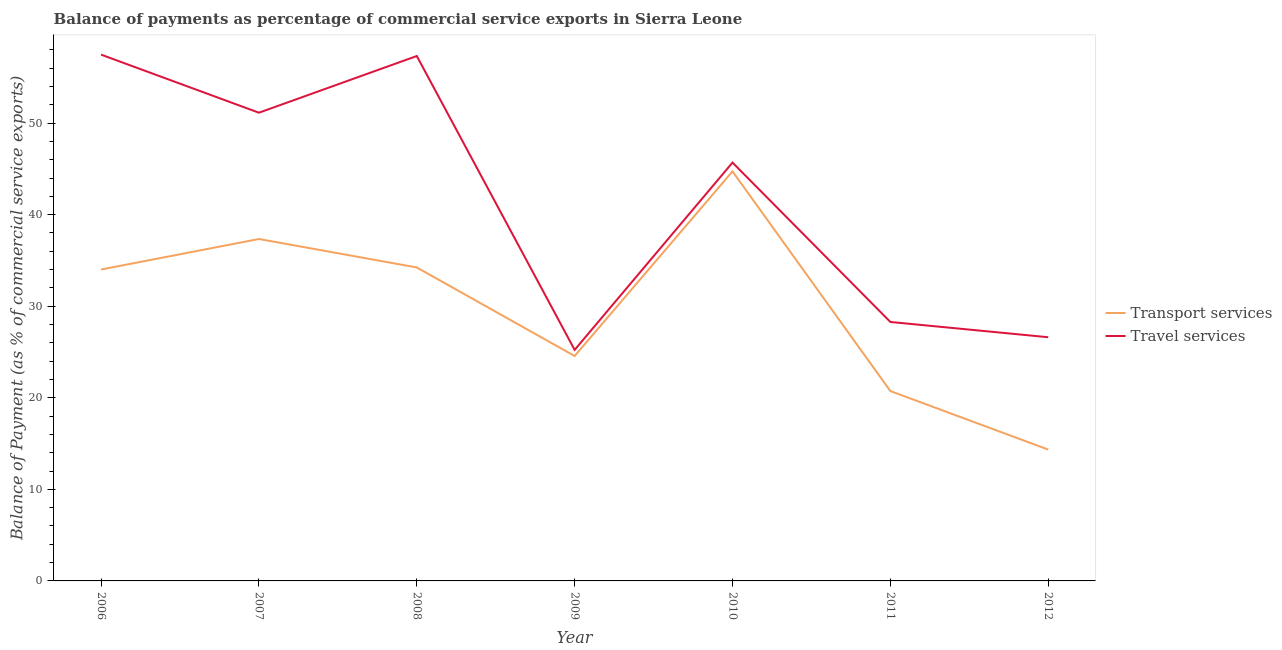How many different coloured lines are there?
Your answer should be compact. 2. Does the line corresponding to balance of payments of travel services intersect with the line corresponding to balance of payments of transport services?
Offer a very short reply. No. Is the number of lines equal to the number of legend labels?
Give a very brief answer. Yes. What is the balance of payments of travel services in 2012?
Provide a succinct answer. 26.61. Across all years, what is the maximum balance of payments of transport services?
Your answer should be compact. 44.72. Across all years, what is the minimum balance of payments of transport services?
Provide a succinct answer. 14.34. In which year was the balance of payments of transport services maximum?
Your answer should be compact. 2010. What is the total balance of payments of travel services in the graph?
Make the answer very short. 291.73. What is the difference between the balance of payments of transport services in 2008 and that in 2010?
Make the answer very short. -10.49. What is the difference between the balance of payments of transport services in 2012 and the balance of payments of travel services in 2006?
Your response must be concise. -43.13. What is the average balance of payments of transport services per year?
Offer a very short reply. 29.99. In the year 2011, what is the difference between the balance of payments of travel services and balance of payments of transport services?
Ensure brevity in your answer.  7.54. What is the ratio of the balance of payments of transport services in 2008 to that in 2010?
Offer a terse response. 0.77. Is the difference between the balance of payments of travel services in 2006 and 2011 greater than the difference between the balance of payments of transport services in 2006 and 2011?
Ensure brevity in your answer.  Yes. What is the difference between the highest and the second highest balance of payments of travel services?
Keep it short and to the point. 0.15. What is the difference between the highest and the lowest balance of payments of transport services?
Your response must be concise. 30.38. In how many years, is the balance of payments of transport services greater than the average balance of payments of transport services taken over all years?
Make the answer very short. 4. Does the balance of payments of transport services monotonically increase over the years?
Your answer should be very brief. No. Is the balance of payments of travel services strictly less than the balance of payments of transport services over the years?
Make the answer very short. No. Does the graph contain any zero values?
Provide a succinct answer. No. Where does the legend appear in the graph?
Give a very brief answer. Center right. How many legend labels are there?
Keep it short and to the point. 2. What is the title of the graph?
Your answer should be very brief. Balance of payments as percentage of commercial service exports in Sierra Leone. Does "Lowest 10% of population" appear as one of the legend labels in the graph?
Give a very brief answer. No. What is the label or title of the Y-axis?
Offer a very short reply. Balance of Payment (as % of commercial service exports). What is the Balance of Payment (as % of commercial service exports) in Transport services in 2006?
Your answer should be compact. 34.01. What is the Balance of Payment (as % of commercial service exports) in Travel services in 2006?
Offer a very short reply. 57.47. What is the Balance of Payment (as % of commercial service exports) of Transport services in 2007?
Give a very brief answer. 37.34. What is the Balance of Payment (as % of commercial service exports) in Travel services in 2007?
Make the answer very short. 51.13. What is the Balance of Payment (as % of commercial service exports) in Transport services in 2008?
Provide a short and direct response. 34.23. What is the Balance of Payment (as % of commercial service exports) in Travel services in 2008?
Provide a succinct answer. 57.32. What is the Balance of Payment (as % of commercial service exports) of Transport services in 2009?
Provide a succinct answer. 24.56. What is the Balance of Payment (as % of commercial service exports) of Travel services in 2009?
Your response must be concise. 25.23. What is the Balance of Payment (as % of commercial service exports) in Transport services in 2010?
Provide a succinct answer. 44.72. What is the Balance of Payment (as % of commercial service exports) in Travel services in 2010?
Make the answer very short. 45.68. What is the Balance of Payment (as % of commercial service exports) in Transport services in 2011?
Offer a terse response. 20.73. What is the Balance of Payment (as % of commercial service exports) in Travel services in 2011?
Offer a very short reply. 28.28. What is the Balance of Payment (as % of commercial service exports) of Transport services in 2012?
Ensure brevity in your answer.  14.34. What is the Balance of Payment (as % of commercial service exports) of Travel services in 2012?
Ensure brevity in your answer.  26.61. Across all years, what is the maximum Balance of Payment (as % of commercial service exports) in Transport services?
Your answer should be compact. 44.72. Across all years, what is the maximum Balance of Payment (as % of commercial service exports) in Travel services?
Make the answer very short. 57.47. Across all years, what is the minimum Balance of Payment (as % of commercial service exports) of Transport services?
Give a very brief answer. 14.34. Across all years, what is the minimum Balance of Payment (as % of commercial service exports) of Travel services?
Your response must be concise. 25.23. What is the total Balance of Payment (as % of commercial service exports) in Transport services in the graph?
Your response must be concise. 209.94. What is the total Balance of Payment (as % of commercial service exports) in Travel services in the graph?
Provide a succinct answer. 291.73. What is the difference between the Balance of Payment (as % of commercial service exports) of Transport services in 2006 and that in 2007?
Give a very brief answer. -3.33. What is the difference between the Balance of Payment (as % of commercial service exports) in Travel services in 2006 and that in 2007?
Your answer should be very brief. 6.34. What is the difference between the Balance of Payment (as % of commercial service exports) in Transport services in 2006 and that in 2008?
Your response must be concise. -0.22. What is the difference between the Balance of Payment (as % of commercial service exports) in Travel services in 2006 and that in 2008?
Your answer should be very brief. 0.15. What is the difference between the Balance of Payment (as % of commercial service exports) in Transport services in 2006 and that in 2009?
Offer a terse response. 9.45. What is the difference between the Balance of Payment (as % of commercial service exports) in Travel services in 2006 and that in 2009?
Provide a short and direct response. 32.24. What is the difference between the Balance of Payment (as % of commercial service exports) in Transport services in 2006 and that in 2010?
Your response must be concise. -10.72. What is the difference between the Balance of Payment (as % of commercial service exports) in Travel services in 2006 and that in 2010?
Your answer should be compact. 11.79. What is the difference between the Balance of Payment (as % of commercial service exports) in Transport services in 2006 and that in 2011?
Your answer should be very brief. 13.27. What is the difference between the Balance of Payment (as % of commercial service exports) in Travel services in 2006 and that in 2011?
Offer a very short reply. 29.19. What is the difference between the Balance of Payment (as % of commercial service exports) of Transport services in 2006 and that in 2012?
Ensure brevity in your answer.  19.67. What is the difference between the Balance of Payment (as % of commercial service exports) in Travel services in 2006 and that in 2012?
Give a very brief answer. 30.86. What is the difference between the Balance of Payment (as % of commercial service exports) of Transport services in 2007 and that in 2008?
Provide a short and direct response. 3.11. What is the difference between the Balance of Payment (as % of commercial service exports) in Travel services in 2007 and that in 2008?
Keep it short and to the point. -6.19. What is the difference between the Balance of Payment (as % of commercial service exports) of Transport services in 2007 and that in 2009?
Give a very brief answer. 12.78. What is the difference between the Balance of Payment (as % of commercial service exports) in Travel services in 2007 and that in 2009?
Your answer should be compact. 25.9. What is the difference between the Balance of Payment (as % of commercial service exports) in Transport services in 2007 and that in 2010?
Your answer should be compact. -7.39. What is the difference between the Balance of Payment (as % of commercial service exports) in Travel services in 2007 and that in 2010?
Make the answer very short. 5.45. What is the difference between the Balance of Payment (as % of commercial service exports) in Transport services in 2007 and that in 2011?
Give a very brief answer. 16.6. What is the difference between the Balance of Payment (as % of commercial service exports) in Travel services in 2007 and that in 2011?
Make the answer very short. 22.85. What is the difference between the Balance of Payment (as % of commercial service exports) of Transport services in 2007 and that in 2012?
Offer a terse response. 23. What is the difference between the Balance of Payment (as % of commercial service exports) in Travel services in 2007 and that in 2012?
Offer a very short reply. 24.52. What is the difference between the Balance of Payment (as % of commercial service exports) of Transport services in 2008 and that in 2009?
Provide a short and direct response. 9.67. What is the difference between the Balance of Payment (as % of commercial service exports) in Travel services in 2008 and that in 2009?
Ensure brevity in your answer.  32.09. What is the difference between the Balance of Payment (as % of commercial service exports) in Transport services in 2008 and that in 2010?
Offer a very short reply. -10.49. What is the difference between the Balance of Payment (as % of commercial service exports) of Travel services in 2008 and that in 2010?
Offer a terse response. 11.64. What is the difference between the Balance of Payment (as % of commercial service exports) in Transport services in 2008 and that in 2011?
Your answer should be compact. 13.5. What is the difference between the Balance of Payment (as % of commercial service exports) of Travel services in 2008 and that in 2011?
Ensure brevity in your answer.  29.04. What is the difference between the Balance of Payment (as % of commercial service exports) of Transport services in 2008 and that in 2012?
Ensure brevity in your answer.  19.89. What is the difference between the Balance of Payment (as % of commercial service exports) of Travel services in 2008 and that in 2012?
Offer a very short reply. 30.71. What is the difference between the Balance of Payment (as % of commercial service exports) in Transport services in 2009 and that in 2010?
Offer a very short reply. -20.16. What is the difference between the Balance of Payment (as % of commercial service exports) in Travel services in 2009 and that in 2010?
Provide a short and direct response. -20.45. What is the difference between the Balance of Payment (as % of commercial service exports) in Transport services in 2009 and that in 2011?
Your answer should be compact. 3.83. What is the difference between the Balance of Payment (as % of commercial service exports) of Travel services in 2009 and that in 2011?
Your answer should be very brief. -3.05. What is the difference between the Balance of Payment (as % of commercial service exports) in Transport services in 2009 and that in 2012?
Provide a succinct answer. 10.22. What is the difference between the Balance of Payment (as % of commercial service exports) of Travel services in 2009 and that in 2012?
Your answer should be very brief. -1.38. What is the difference between the Balance of Payment (as % of commercial service exports) of Transport services in 2010 and that in 2011?
Make the answer very short. 23.99. What is the difference between the Balance of Payment (as % of commercial service exports) in Travel services in 2010 and that in 2011?
Your answer should be very brief. 17.41. What is the difference between the Balance of Payment (as % of commercial service exports) in Transport services in 2010 and that in 2012?
Provide a short and direct response. 30.38. What is the difference between the Balance of Payment (as % of commercial service exports) in Travel services in 2010 and that in 2012?
Make the answer very short. 19.07. What is the difference between the Balance of Payment (as % of commercial service exports) of Transport services in 2011 and that in 2012?
Keep it short and to the point. 6.39. What is the difference between the Balance of Payment (as % of commercial service exports) in Travel services in 2011 and that in 2012?
Offer a terse response. 1.67. What is the difference between the Balance of Payment (as % of commercial service exports) of Transport services in 2006 and the Balance of Payment (as % of commercial service exports) of Travel services in 2007?
Provide a short and direct response. -17.12. What is the difference between the Balance of Payment (as % of commercial service exports) of Transport services in 2006 and the Balance of Payment (as % of commercial service exports) of Travel services in 2008?
Keep it short and to the point. -23.31. What is the difference between the Balance of Payment (as % of commercial service exports) in Transport services in 2006 and the Balance of Payment (as % of commercial service exports) in Travel services in 2009?
Offer a terse response. 8.78. What is the difference between the Balance of Payment (as % of commercial service exports) of Transport services in 2006 and the Balance of Payment (as % of commercial service exports) of Travel services in 2010?
Your answer should be compact. -11.68. What is the difference between the Balance of Payment (as % of commercial service exports) in Transport services in 2006 and the Balance of Payment (as % of commercial service exports) in Travel services in 2011?
Make the answer very short. 5.73. What is the difference between the Balance of Payment (as % of commercial service exports) of Transport services in 2006 and the Balance of Payment (as % of commercial service exports) of Travel services in 2012?
Offer a very short reply. 7.4. What is the difference between the Balance of Payment (as % of commercial service exports) in Transport services in 2007 and the Balance of Payment (as % of commercial service exports) in Travel services in 2008?
Offer a very short reply. -19.98. What is the difference between the Balance of Payment (as % of commercial service exports) of Transport services in 2007 and the Balance of Payment (as % of commercial service exports) of Travel services in 2009?
Give a very brief answer. 12.11. What is the difference between the Balance of Payment (as % of commercial service exports) in Transport services in 2007 and the Balance of Payment (as % of commercial service exports) in Travel services in 2010?
Provide a short and direct response. -8.35. What is the difference between the Balance of Payment (as % of commercial service exports) in Transport services in 2007 and the Balance of Payment (as % of commercial service exports) in Travel services in 2011?
Keep it short and to the point. 9.06. What is the difference between the Balance of Payment (as % of commercial service exports) of Transport services in 2007 and the Balance of Payment (as % of commercial service exports) of Travel services in 2012?
Give a very brief answer. 10.73. What is the difference between the Balance of Payment (as % of commercial service exports) of Transport services in 2008 and the Balance of Payment (as % of commercial service exports) of Travel services in 2009?
Your response must be concise. 9. What is the difference between the Balance of Payment (as % of commercial service exports) in Transport services in 2008 and the Balance of Payment (as % of commercial service exports) in Travel services in 2010?
Your response must be concise. -11.45. What is the difference between the Balance of Payment (as % of commercial service exports) of Transport services in 2008 and the Balance of Payment (as % of commercial service exports) of Travel services in 2011?
Make the answer very short. 5.95. What is the difference between the Balance of Payment (as % of commercial service exports) in Transport services in 2008 and the Balance of Payment (as % of commercial service exports) in Travel services in 2012?
Offer a terse response. 7.62. What is the difference between the Balance of Payment (as % of commercial service exports) in Transport services in 2009 and the Balance of Payment (as % of commercial service exports) in Travel services in 2010?
Offer a terse response. -21.12. What is the difference between the Balance of Payment (as % of commercial service exports) of Transport services in 2009 and the Balance of Payment (as % of commercial service exports) of Travel services in 2011?
Provide a short and direct response. -3.72. What is the difference between the Balance of Payment (as % of commercial service exports) of Transport services in 2009 and the Balance of Payment (as % of commercial service exports) of Travel services in 2012?
Your answer should be compact. -2.05. What is the difference between the Balance of Payment (as % of commercial service exports) in Transport services in 2010 and the Balance of Payment (as % of commercial service exports) in Travel services in 2011?
Offer a terse response. 16.45. What is the difference between the Balance of Payment (as % of commercial service exports) in Transport services in 2010 and the Balance of Payment (as % of commercial service exports) in Travel services in 2012?
Provide a succinct answer. 18.11. What is the difference between the Balance of Payment (as % of commercial service exports) in Transport services in 2011 and the Balance of Payment (as % of commercial service exports) in Travel services in 2012?
Offer a very short reply. -5.88. What is the average Balance of Payment (as % of commercial service exports) in Transport services per year?
Make the answer very short. 29.99. What is the average Balance of Payment (as % of commercial service exports) in Travel services per year?
Offer a very short reply. 41.68. In the year 2006, what is the difference between the Balance of Payment (as % of commercial service exports) of Transport services and Balance of Payment (as % of commercial service exports) of Travel services?
Provide a short and direct response. -23.46. In the year 2007, what is the difference between the Balance of Payment (as % of commercial service exports) of Transport services and Balance of Payment (as % of commercial service exports) of Travel services?
Your response must be concise. -13.79. In the year 2008, what is the difference between the Balance of Payment (as % of commercial service exports) of Transport services and Balance of Payment (as % of commercial service exports) of Travel services?
Keep it short and to the point. -23.09. In the year 2009, what is the difference between the Balance of Payment (as % of commercial service exports) in Transport services and Balance of Payment (as % of commercial service exports) in Travel services?
Your answer should be compact. -0.67. In the year 2010, what is the difference between the Balance of Payment (as % of commercial service exports) of Transport services and Balance of Payment (as % of commercial service exports) of Travel services?
Provide a succinct answer. -0.96. In the year 2011, what is the difference between the Balance of Payment (as % of commercial service exports) in Transport services and Balance of Payment (as % of commercial service exports) in Travel services?
Provide a short and direct response. -7.54. In the year 2012, what is the difference between the Balance of Payment (as % of commercial service exports) of Transport services and Balance of Payment (as % of commercial service exports) of Travel services?
Your response must be concise. -12.27. What is the ratio of the Balance of Payment (as % of commercial service exports) of Transport services in 2006 to that in 2007?
Give a very brief answer. 0.91. What is the ratio of the Balance of Payment (as % of commercial service exports) of Travel services in 2006 to that in 2007?
Your response must be concise. 1.12. What is the ratio of the Balance of Payment (as % of commercial service exports) of Travel services in 2006 to that in 2008?
Your response must be concise. 1. What is the ratio of the Balance of Payment (as % of commercial service exports) in Transport services in 2006 to that in 2009?
Give a very brief answer. 1.38. What is the ratio of the Balance of Payment (as % of commercial service exports) of Travel services in 2006 to that in 2009?
Provide a succinct answer. 2.28. What is the ratio of the Balance of Payment (as % of commercial service exports) of Transport services in 2006 to that in 2010?
Ensure brevity in your answer.  0.76. What is the ratio of the Balance of Payment (as % of commercial service exports) in Travel services in 2006 to that in 2010?
Make the answer very short. 1.26. What is the ratio of the Balance of Payment (as % of commercial service exports) of Transport services in 2006 to that in 2011?
Give a very brief answer. 1.64. What is the ratio of the Balance of Payment (as % of commercial service exports) in Travel services in 2006 to that in 2011?
Provide a short and direct response. 2.03. What is the ratio of the Balance of Payment (as % of commercial service exports) in Transport services in 2006 to that in 2012?
Your answer should be compact. 2.37. What is the ratio of the Balance of Payment (as % of commercial service exports) in Travel services in 2006 to that in 2012?
Make the answer very short. 2.16. What is the ratio of the Balance of Payment (as % of commercial service exports) in Transport services in 2007 to that in 2008?
Your answer should be very brief. 1.09. What is the ratio of the Balance of Payment (as % of commercial service exports) of Travel services in 2007 to that in 2008?
Make the answer very short. 0.89. What is the ratio of the Balance of Payment (as % of commercial service exports) of Transport services in 2007 to that in 2009?
Provide a short and direct response. 1.52. What is the ratio of the Balance of Payment (as % of commercial service exports) in Travel services in 2007 to that in 2009?
Give a very brief answer. 2.03. What is the ratio of the Balance of Payment (as % of commercial service exports) of Transport services in 2007 to that in 2010?
Provide a short and direct response. 0.83. What is the ratio of the Balance of Payment (as % of commercial service exports) in Travel services in 2007 to that in 2010?
Your response must be concise. 1.12. What is the ratio of the Balance of Payment (as % of commercial service exports) in Transport services in 2007 to that in 2011?
Your answer should be compact. 1.8. What is the ratio of the Balance of Payment (as % of commercial service exports) in Travel services in 2007 to that in 2011?
Offer a terse response. 1.81. What is the ratio of the Balance of Payment (as % of commercial service exports) in Transport services in 2007 to that in 2012?
Give a very brief answer. 2.6. What is the ratio of the Balance of Payment (as % of commercial service exports) in Travel services in 2007 to that in 2012?
Give a very brief answer. 1.92. What is the ratio of the Balance of Payment (as % of commercial service exports) of Transport services in 2008 to that in 2009?
Your response must be concise. 1.39. What is the ratio of the Balance of Payment (as % of commercial service exports) of Travel services in 2008 to that in 2009?
Your answer should be compact. 2.27. What is the ratio of the Balance of Payment (as % of commercial service exports) of Transport services in 2008 to that in 2010?
Your answer should be compact. 0.77. What is the ratio of the Balance of Payment (as % of commercial service exports) of Travel services in 2008 to that in 2010?
Provide a succinct answer. 1.25. What is the ratio of the Balance of Payment (as % of commercial service exports) in Transport services in 2008 to that in 2011?
Your response must be concise. 1.65. What is the ratio of the Balance of Payment (as % of commercial service exports) of Travel services in 2008 to that in 2011?
Offer a terse response. 2.03. What is the ratio of the Balance of Payment (as % of commercial service exports) of Transport services in 2008 to that in 2012?
Keep it short and to the point. 2.39. What is the ratio of the Balance of Payment (as % of commercial service exports) in Travel services in 2008 to that in 2012?
Keep it short and to the point. 2.15. What is the ratio of the Balance of Payment (as % of commercial service exports) in Transport services in 2009 to that in 2010?
Make the answer very short. 0.55. What is the ratio of the Balance of Payment (as % of commercial service exports) in Travel services in 2009 to that in 2010?
Offer a very short reply. 0.55. What is the ratio of the Balance of Payment (as % of commercial service exports) of Transport services in 2009 to that in 2011?
Ensure brevity in your answer.  1.18. What is the ratio of the Balance of Payment (as % of commercial service exports) in Travel services in 2009 to that in 2011?
Your response must be concise. 0.89. What is the ratio of the Balance of Payment (as % of commercial service exports) of Transport services in 2009 to that in 2012?
Keep it short and to the point. 1.71. What is the ratio of the Balance of Payment (as % of commercial service exports) in Travel services in 2009 to that in 2012?
Give a very brief answer. 0.95. What is the ratio of the Balance of Payment (as % of commercial service exports) of Transport services in 2010 to that in 2011?
Give a very brief answer. 2.16. What is the ratio of the Balance of Payment (as % of commercial service exports) in Travel services in 2010 to that in 2011?
Your answer should be compact. 1.62. What is the ratio of the Balance of Payment (as % of commercial service exports) in Transport services in 2010 to that in 2012?
Provide a succinct answer. 3.12. What is the ratio of the Balance of Payment (as % of commercial service exports) in Travel services in 2010 to that in 2012?
Give a very brief answer. 1.72. What is the ratio of the Balance of Payment (as % of commercial service exports) of Transport services in 2011 to that in 2012?
Ensure brevity in your answer.  1.45. What is the ratio of the Balance of Payment (as % of commercial service exports) in Travel services in 2011 to that in 2012?
Your response must be concise. 1.06. What is the difference between the highest and the second highest Balance of Payment (as % of commercial service exports) in Transport services?
Provide a succinct answer. 7.39. What is the difference between the highest and the second highest Balance of Payment (as % of commercial service exports) of Travel services?
Provide a succinct answer. 0.15. What is the difference between the highest and the lowest Balance of Payment (as % of commercial service exports) of Transport services?
Make the answer very short. 30.38. What is the difference between the highest and the lowest Balance of Payment (as % of commercial service exports) in Travel services?
Provide a succinct answer. 32.24. 